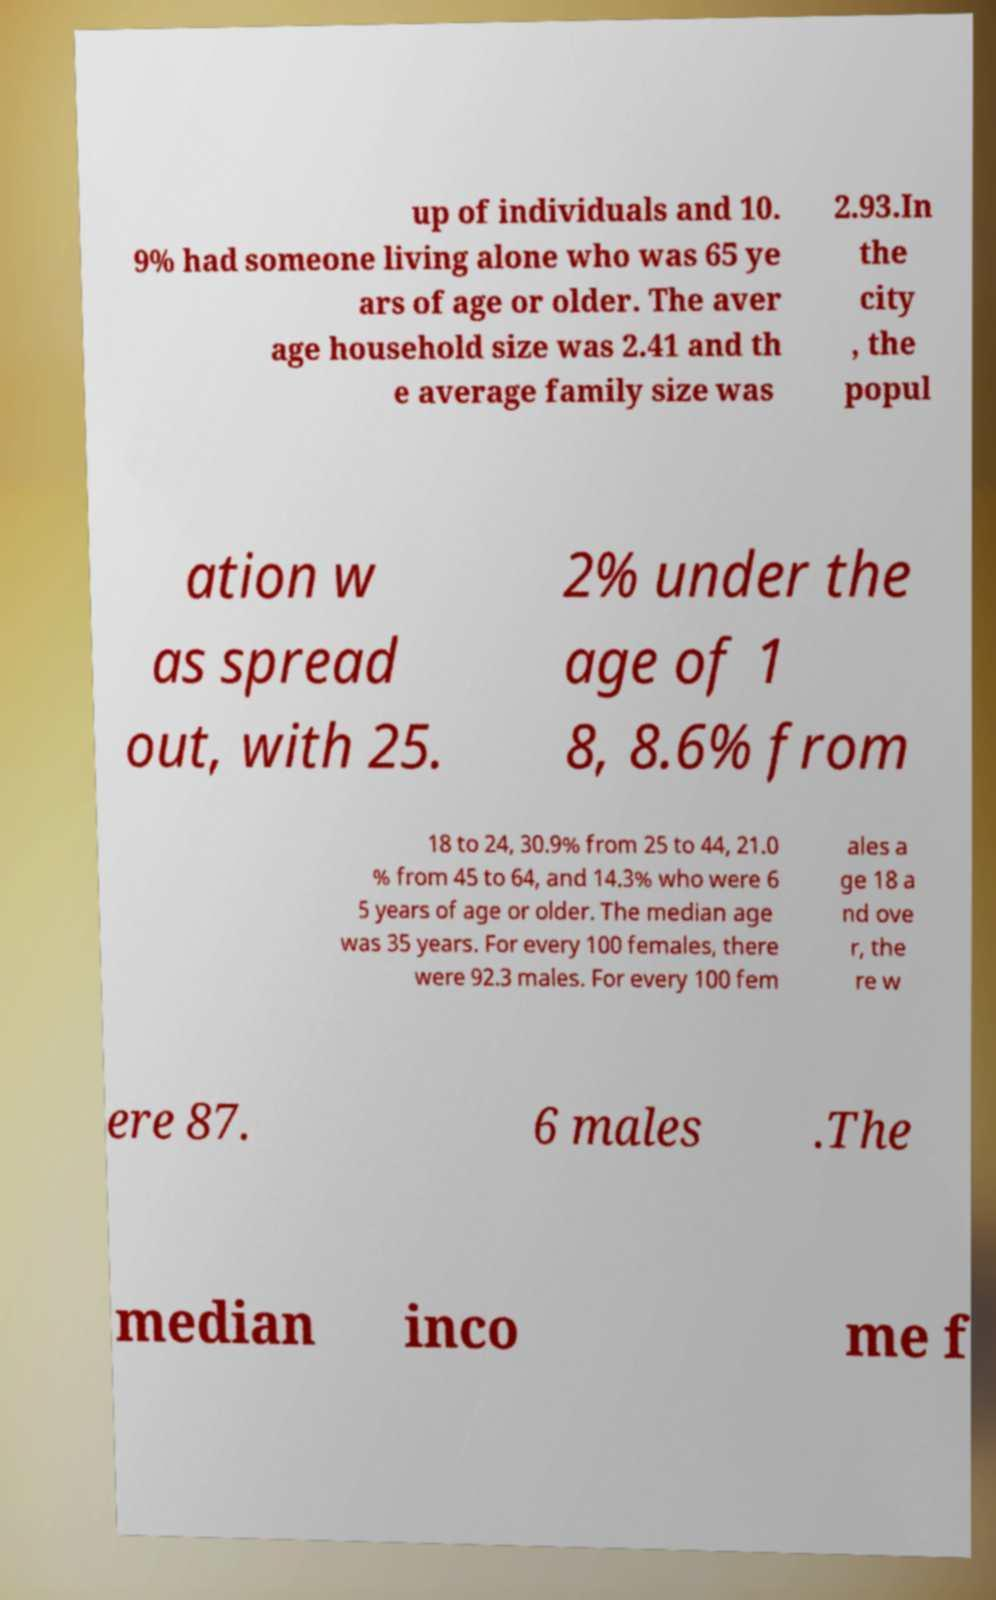Can you accurately transcribe the text from the provided image for me? up of individuals and 10. 9% had someone living alone who was 65 ye ars of age or older. The aver age household size was 2.41 and th e average family size was 2.93.In the city , the popul ation w as spread out, with 25. 2% under the age of 1 8, 8.6% from 18 to 24, 30.9% from 25 to 44, 21.0 % from 45 to 64, and 14.3% who were 6 5 years of age or older. The median age was 35 years. For every 100 females, there were 92.3 males. For every 100 fem ales a ge 18 a nd ove r, the re w ere 87. 6 males .The median inco me f 